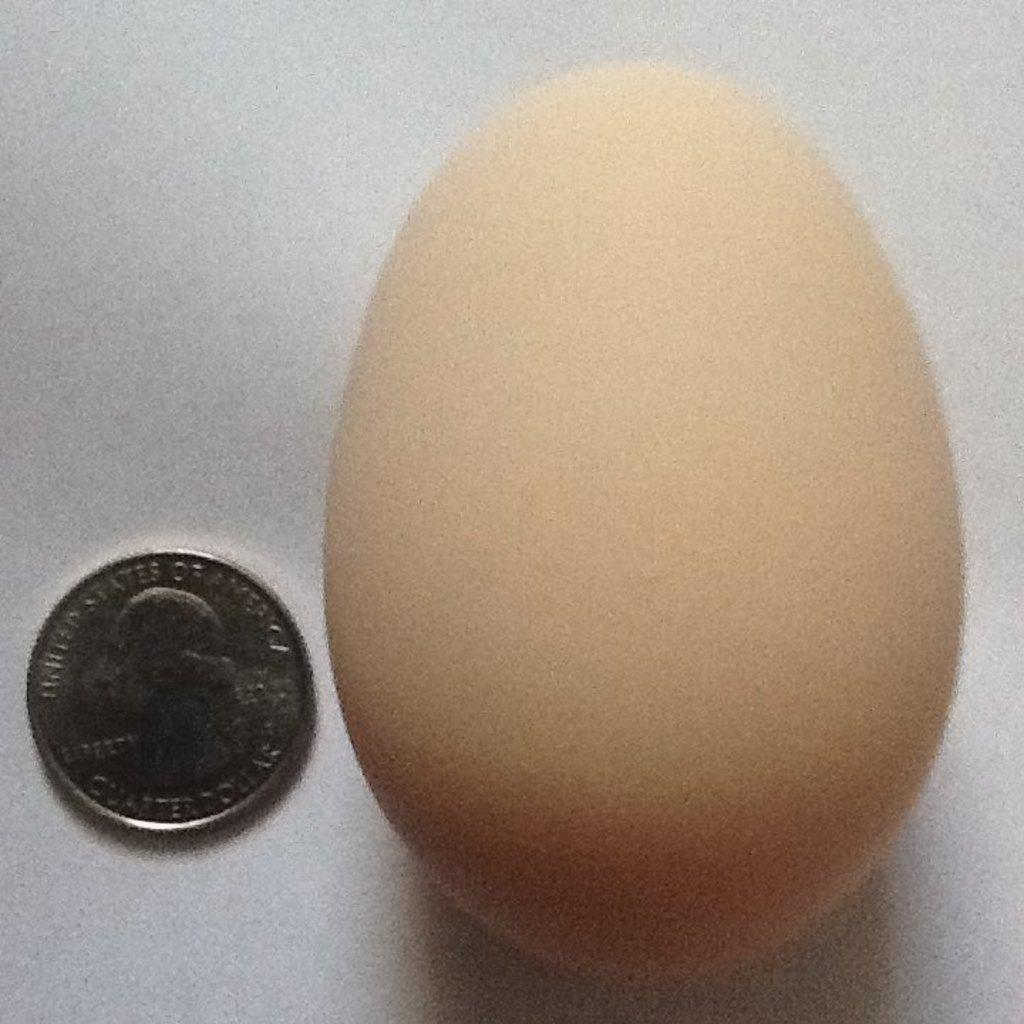What is one of the objects present in the image? There is an egg in the image. What is another object present in the image? There is a coin in the image. Can you describe the location of the egg and coin in the image? The egg and coin are on an object. What type of hose can be seen connected to the egg in the image? There is no hose connected to the egg in the image. What type of nut is visible on the coin in the image? There is no nut visible on the coin in the image. 